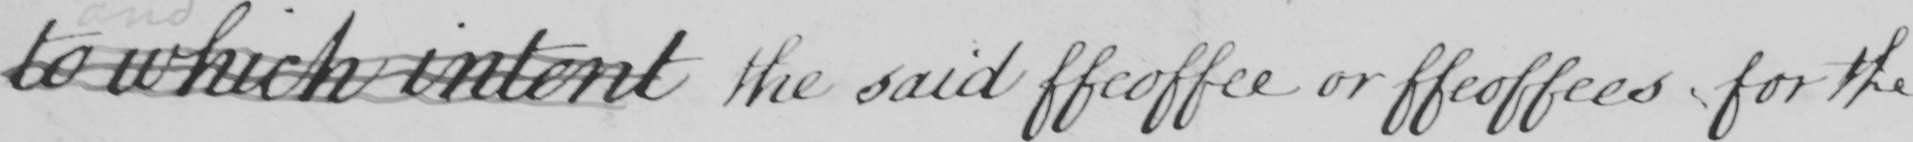Can you read and transcribe this handwriting? to which intent the said ffeoffee or ffeoffees for the 